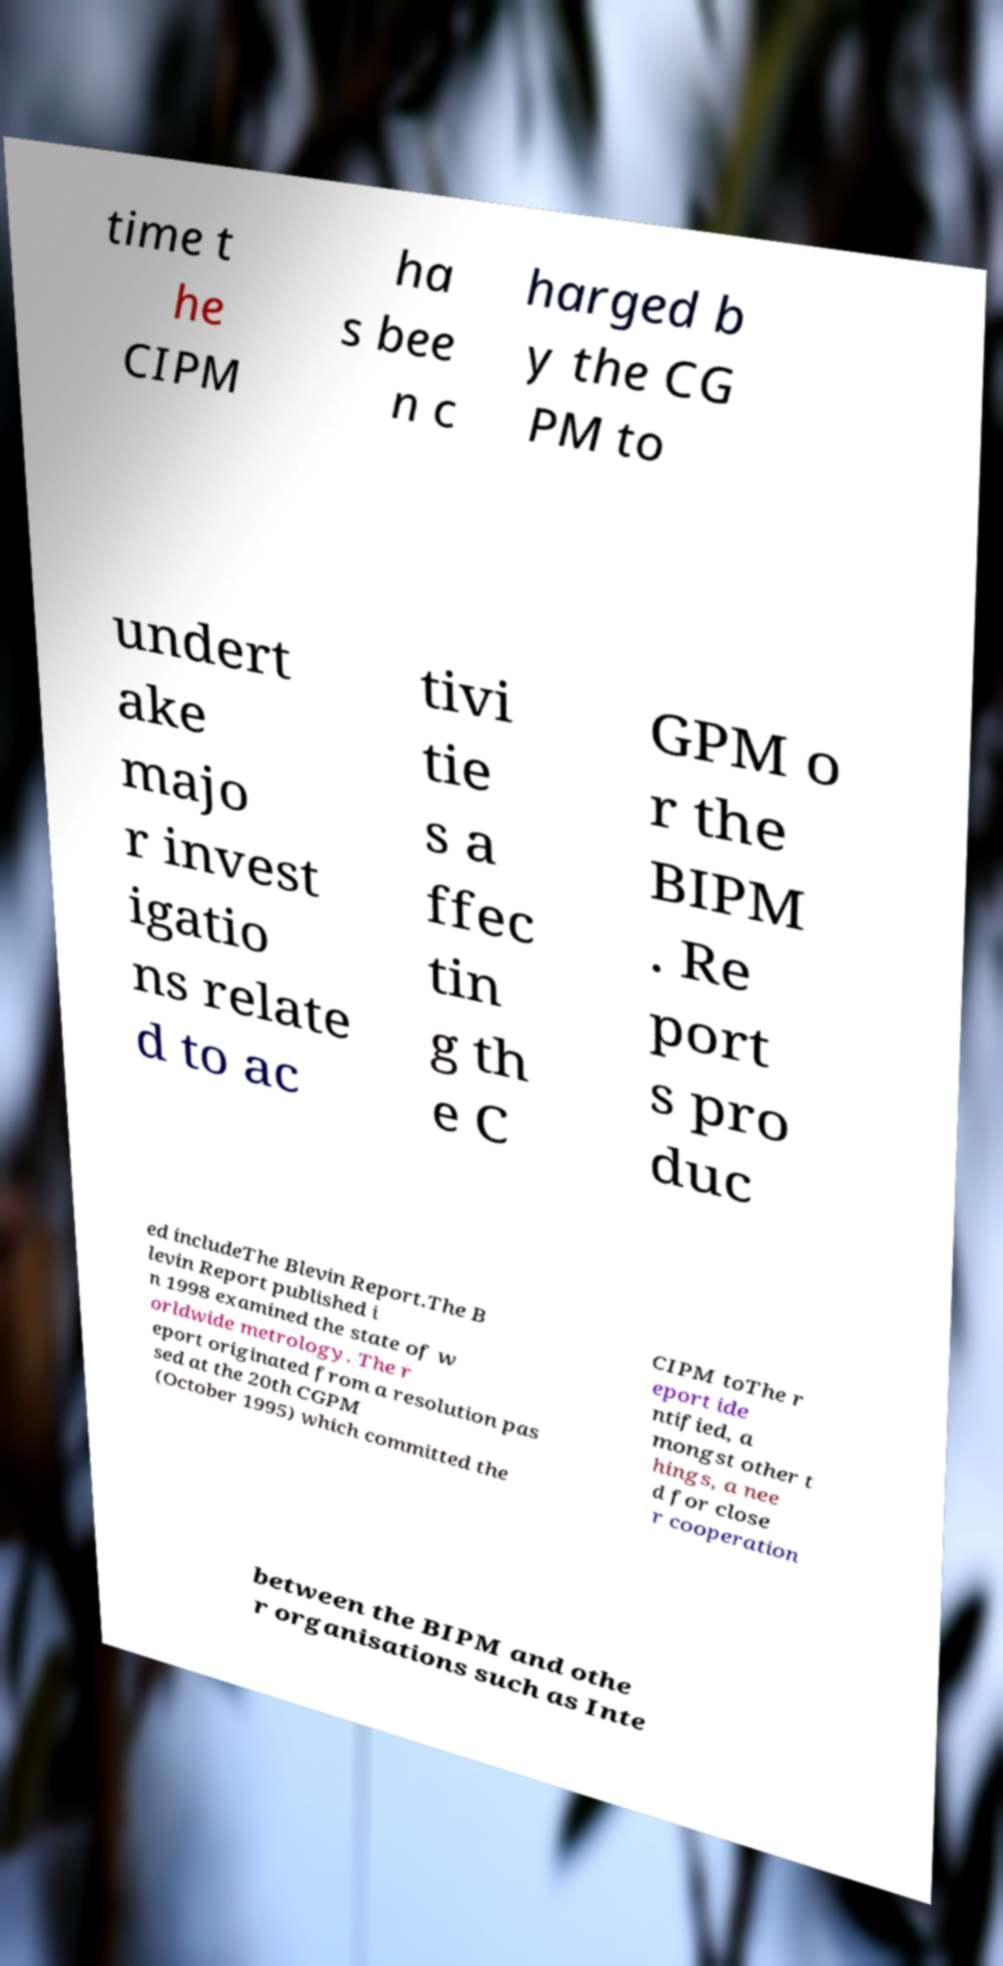Please identify and transcribe the text found in this image. time t he CIPM ha s bee n c harged b y the CG PM to undert ake majo r invest igatio ns relate d to ac tivi tie s a ffec tin g th e C GPM o r the BIPM . Re port s pro duc ed includeThe Blevin Report.The B levin Report published i n 1998 examined the state of w orldwide metrology. The r eport originated from a resolution pas sed at the 20th CGPM (October 1995) which committed the CIPM toThe r eport ide ntified, a mongst other t hings, a nee d for close r cooperation between the BIPM and othe r organisations such as Inte 